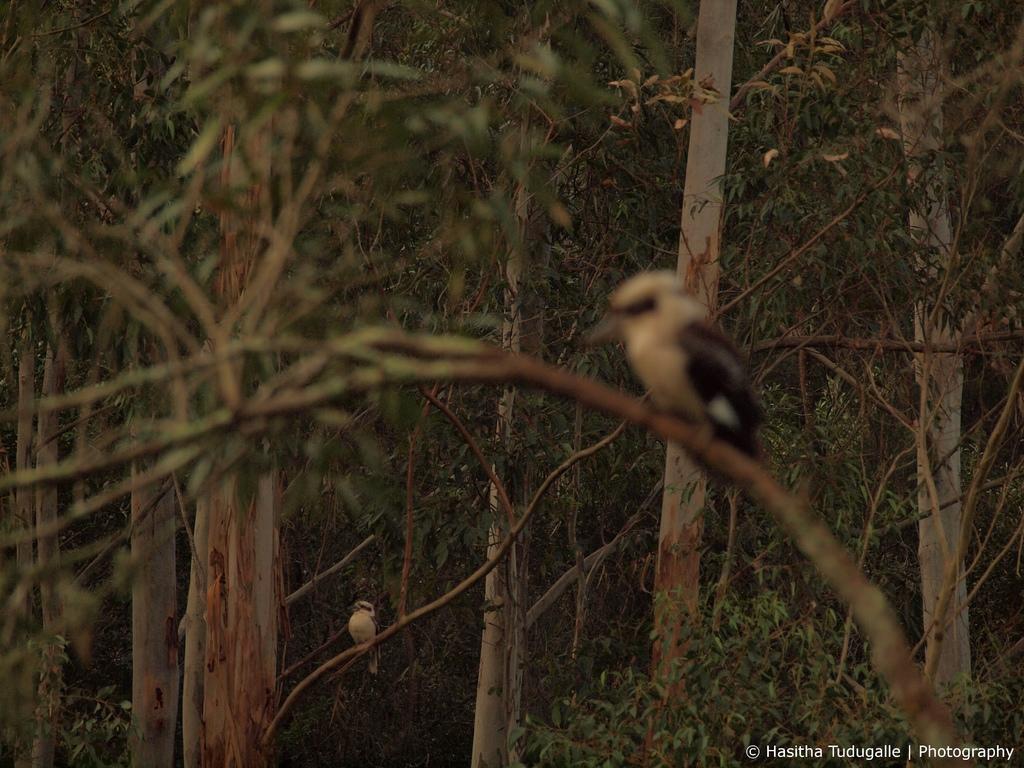Describe this image in one or two sentences. In the foreground of the picture we can see leaves, stems, branch and a bird. In the background there are trees, bird and plants. At the bottom right corner there is text. 